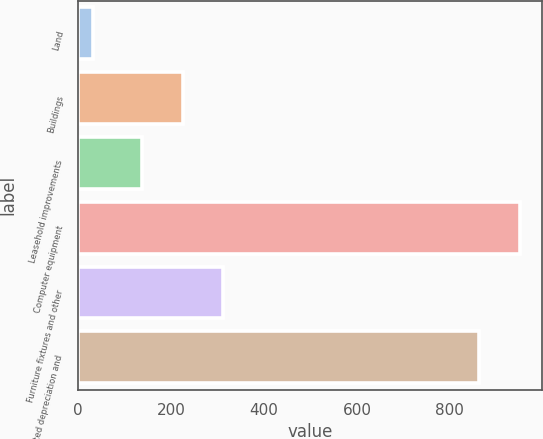<chart> <loc_0><loc_0><loc_500><loc_500><bar_chart><fcel>Land<fcel>Buildings<fcel>Leasehold improvements<fcel>Computer equipment<fcel>Furniture fixtures and other<fcel>Accumulated depreciation and<nl><fcel>31<fcel>224.8<fcel>137<fcel>949.8<fcel>312.6<fcel>862<nl></chart> 